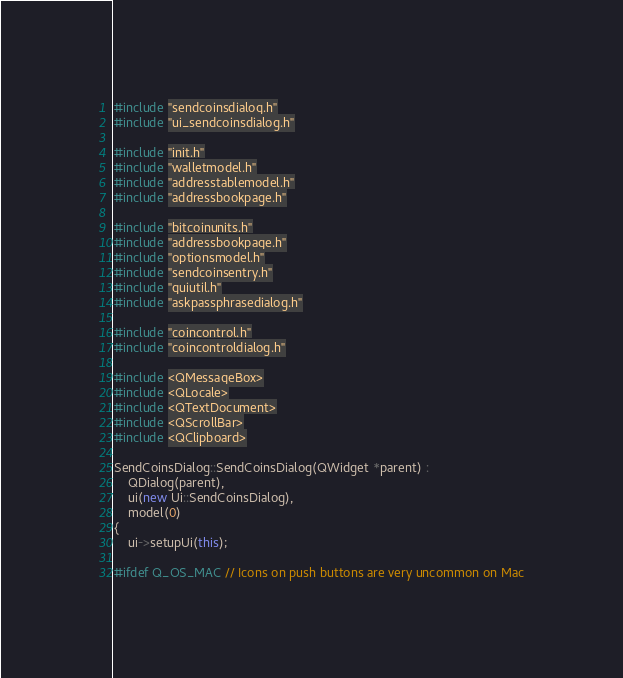<code> <loc_0><loc_0><loc_500><loc_500><_C++_>#include "sendcoinsdialog.h"
#include "ui_sendcoinsdialog.h"

#include "init.h"
#include "walletmodel.h"
#include "addresstablemodel.h"
#include "addressbookpage.h"

#include "bitcoinunits.h"
#include "addressbookpage.h"
#include "optionsmodel.h"
#include "sendcoinsentry.h"
#include "guiutil.h"
#include "askpassphrasedialog.h"

#include "coincontrol.h"
#include "coincontroldialog.h"

#include <QMessageBox>
#include <QLocale>
#include <QTextDocument>
#include <QScrollBar>
#include <QClipboard>

SendCoinsDialog::SendCoinsDialog(QWidget *parent) :
    QDialog(parent),
    ui(new Ui::SendCoinsDialog),
    model(0)
{
    ui->setupUi(this);

#ifdef Q_OS_MAC // Icons on push buttons are very uncommon on Mac</code> 